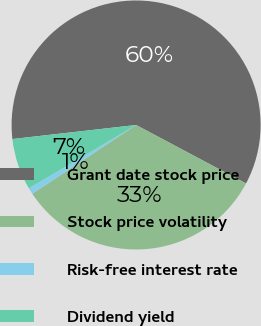Convert chart to OTSL. <chart><loc_0><loc_0><loc_500><loc_500><pie_chart><fcel>Grant date stock price<fcel>Stock price volatility<fcel>Risk-free interest rate<fcel>Dividend yield<nl><fcel>59.58%<fcel>32.91%<fcel>0.82%<fcel>6.69%<nl></chart> 